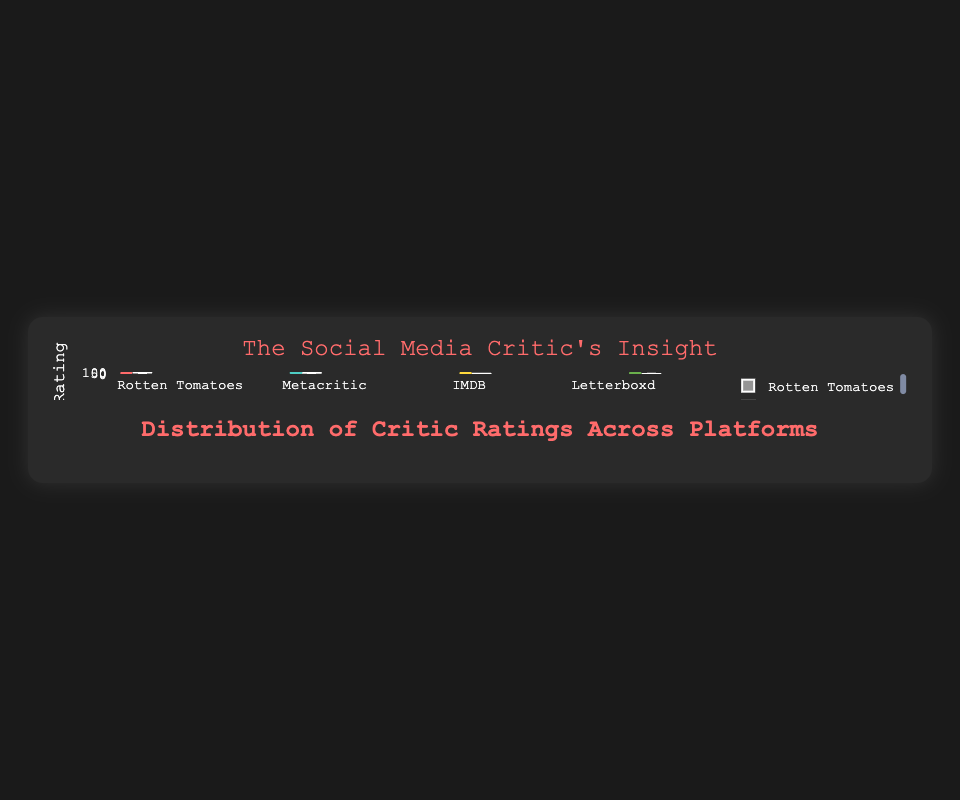How many review platforms are showing in the figure? The figure displays four distinct sets of box plots, representing four review platforms.
Answer: Four What's the title of the figure? The title of the figure is displayed at the top center with larger and distinct text. It is "The Social Media Critic's Insight".
Answer: The Social Media Critic's Insight Which review platform has the highest median rating? The median rating is represented by the line inside the box. Among the platforms, Rotten Tomatoes has the box with the highest center line.
Answer: Rotten Tomatoes What's the lowest rating given on Rotten Tomatoes? The lowest rating is represented by the bottom whisker of the Rotten Tomatoes box plot. It is around 55.
Answer: 55 On which platform are the ratings most closely grouped together? The platform with the smallest interquartile range (the height of the box) shows the most closely grouped ratings. Metacritic's box plot appears the narrowest among all, suggesting tightly grouped ratings.
Answer: Metacritic What is the interquartile range of the ratings on IMDB? The interquartile range (IQR) is the span between the first quartile (Q1, bottom of the box) and third quartile (Q3, top of the box). For IMDB, Q1 is approximately 7.3, and Q3 is approximately 8.3, thus the IQR is 8.3 - 7.3 = 1.0.
Answer: 1.0 Which platform has the widest spread of ratings? The spread can be gauged by the length between the whiskers (minimum to maximum). Rotten Tomatoes has the longest whiskers, indicating the widest spread of ratings.
Answer: Rotten Tomatoes Are there any outliers in the Letterboxd ratings? Outliers in box plots are typically represented by points lying outside the whiskers. The Letterboxd box plot does not show any points outside the whiskers.
Answer: No If you were to average the median ratings of all platforms, what would it be? First, find the median for each platform: Rotten Tomatoes (~78), Metacritic (~70), IMDB (~7.5), and Letterboxd (~4). Convert all ratings to a comparable scale (or convert 7.5 and 4 to percentages out of 10) before averaging: (78 + 70 + 75 + 40) / 4 = 65.75.
Answer: 65.75 Which platform shows the most variability in ratings if you consider IQR as a measure of variability? The interquartile range gives a measure of variability within the middle 50% of the data. Rotten Tomatoes has the largest IQR.
Answer: Rotten Tomatoes 